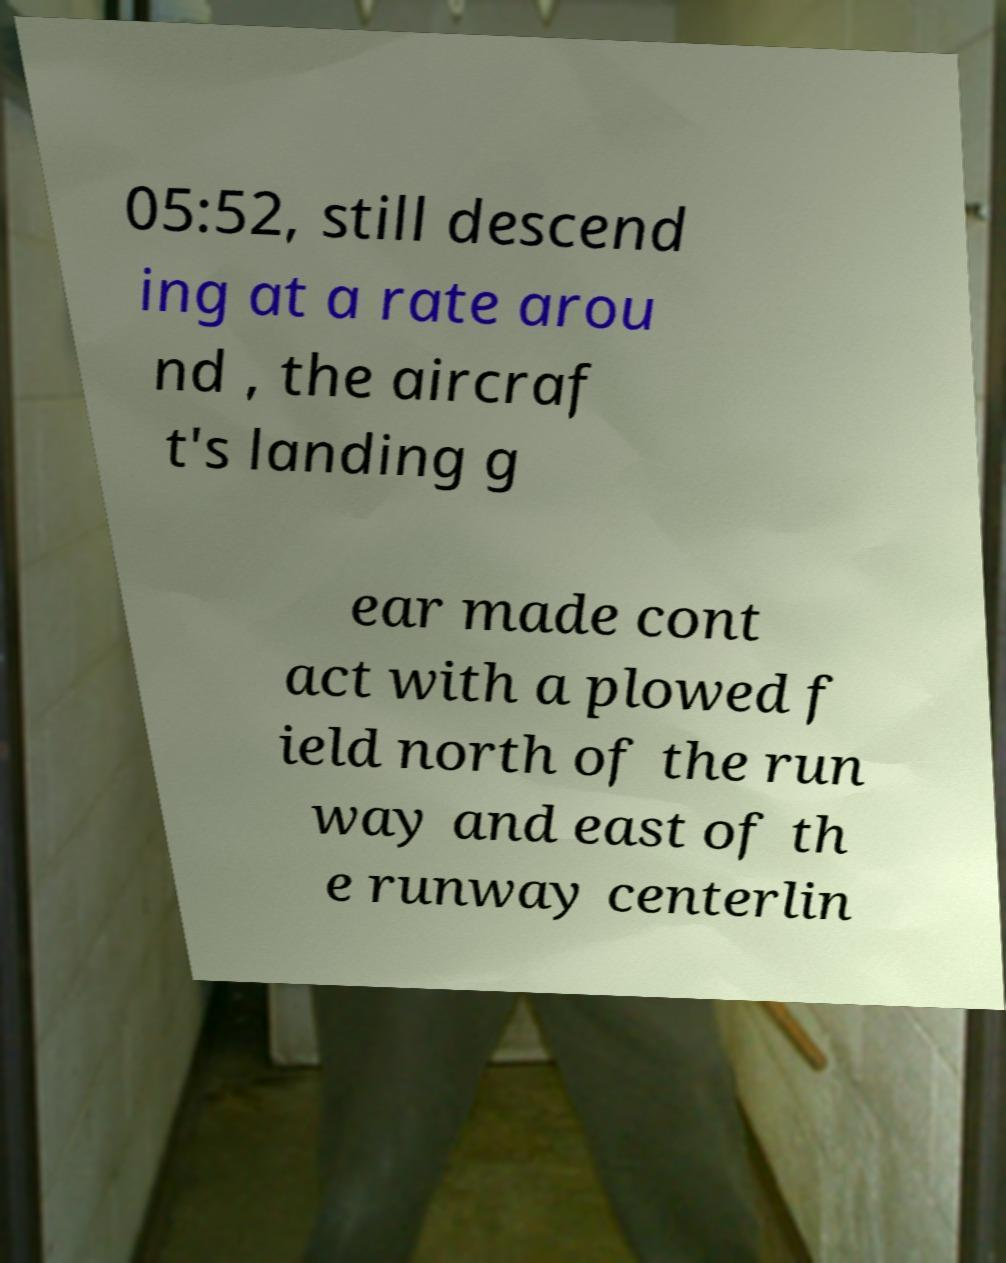What messages or text are displayed in this image? I need them in a readable, typed format. 05:52, still descend ing at a rate arou nd , the aircraf t's landing g ear made cont act with a plowed f ield north of the run way and east of th e runway centerlin 